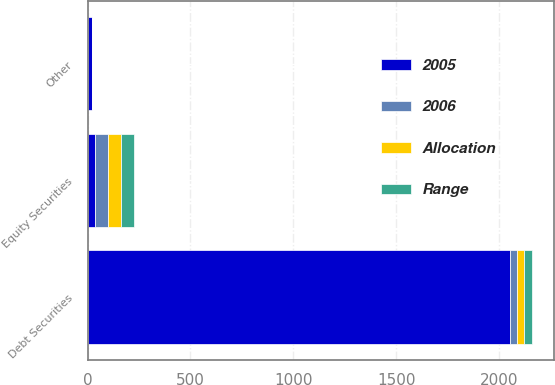<chart> <loc_0><loc_0><loc_500><loc_500><stacked_bar_chart><ecel><fcel>Equity Securities<fcel>Debt Securities<fcel>Other<nl><fcel>2005<fcel>36<fcel>2050<fcel>20<nl><fcel>2006<fcel>63<fcel>36<fcel>1<nl><fcel>Range<fcel>62<fcel>37<fcel>1<nl><fcel>Allocation<fcel>64<fcel>35<fcel>1<nl></chart> 